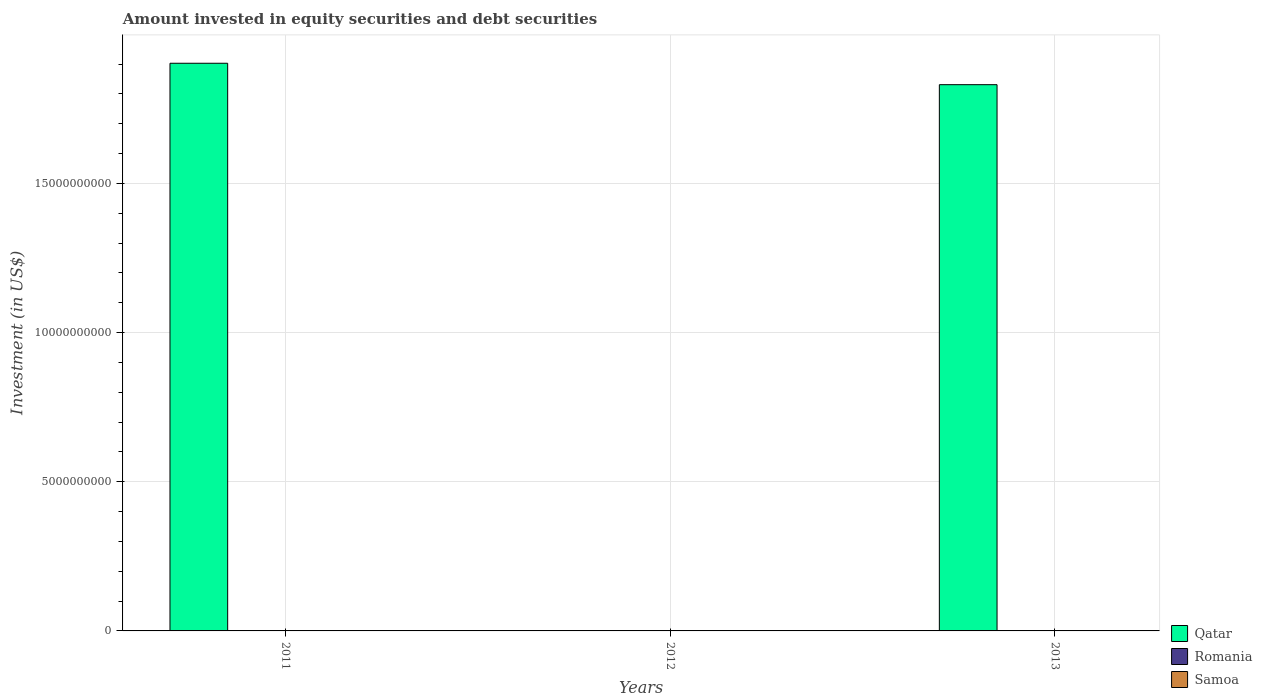Are the number of bars on each tick of the X-axis equal?
Provide a short and direct response. No. What is the label of the 3rd group of bars from the left?
Keep it short and to the point. 2013. What is the amount invested in equity securities and debt securities in Qatar in 2011?
Provide a succinct answer. 1.90e+1. Across all years, what is the maximum amount invested in equity securities and debt securities in Qatar?
Offer a terse response. 1.90e+1. In which year was the amount invested in equity securities and debt securities in Samoa maximum?
Your answer should be very brief. 2012. What is the total amount invested in equity securities and debt securities in Samoa in the graph?
Make the answer very short. 1.20e+07. What is the difference between the amount invested in equity securities and debt securities in Qatar in 2011 and that in 2013?
Offer a very short reply. 7.18e+08. What is the difference between the amount invested in equity securities and debt securities in Samoa in 2011 and the amount invested in equity securities and debt securities in Romania in 2012?
Provide a short and direct response. 3.80e+05. In the year 2011, what is the difference between the amount invested in equity securities and debt securities in Samoa and amount invested in equity securities and debt securities in Qatar?
Your answer should be very brief. -1.90e+1. In how many years, is the amount invested in equity securities and debt securities in Samoa greater than 4000000000 US$?
Your answer should be compact. 0. What is the ratio of the amount invested in equity securities and debt securities in Qatar in 2011 to that in 2013?
Your response must be concise. 1.04. Is the difference between the amount invested in equity securities and debt securities in Samoa in 2011 and 2013 greater than the difference between the amount invested in equity securities and debt securities in Qatar in 2011 and 2013?
Provide a short and direct response. No. What is the difference between the highest and the second highest amount invested in equity securities and debt securities in Samoa?
Your response must be concise. 8.18e+06. What is the difference between the highest and the lowest amount invested in equity securities and debt securities in Samoa?
Your response must be concise. 9.52e+06. Is the sum of the amount invested in equity securities and debt securities in Samoa in 2012 and 2013 greater than the maximum amount invested in equity securities and debt securities in Romania across all years?
Provide a short and direct response. Yes. Is it the case that in every year, the sum of the amount invested in equity securities and debt securities in Samoa and amount invested in equity securities and debt securities in Romania is greater than the amount invested in equity securities and debt securities in Qatar?
Provide a short and direct response. No. How many bars are there?
Give a very brief answer. 5. How many years are there in the graph?
Make the answer very short. 3. Are the values on the major ticks of Y-axis written in scientific E-notation?
Your answer should be compact. No. Does the graph contain any zero values?
Give a very brief answer. Yes. Does the graph contain grids?
Ensure brevity in your answer.  Yes. Where does the legend appear in the graph?
Keep it short and to the point. Bottom right. How many legend labels are there?
Your answer should be compact. 3. What is the title of the graph?
Ensure brevity in your answer.  Amount invested in equity securities and debt securities. What is the label or title of the Y-axis?
Keep it short and to the point. Investment (in US$). What is the Investment (in US$) of Qatar in 2011?
Make the answer very short. 1.90e+1. What is the Investment (in US$) in Romania in 2011?
Offer a very short reply. 0. What is the Investment (in US$) of Samoa in 2011?
Your answer should be compact. 3.80e+05. What is the Investment (in US$) in Romania in 2012?
Provide a succinct answer. 0. What is the Investment (in US$) in Samoa in 2012?
Offer a terse response. 9.90e+06. What is the Investment (in US$) in Qatar in 2013?
Your response must be concise. 1.83e+1. What is the Investment (in US$) in Romania in 2013?
Keep it short and to the point. 0. What is the Investment (in US$) of Samoa in 2013?
Offer a terse response. 1.72e+06. Across all years, what is the maximum Investment (in US$) in Qatar?
Offer a terse response. 1.90e+1. Across all years, what is the maximum Investment (in US$) of Samoa?
Give a very brief answer. 9.90e+06. Across all years, what is the minimum Investment (in US$) of Samoa?
Keep it short and to the point. 3.80e+05. What is the total Investment (in US$) of Qatar in the graph?
Your response must be concise. 3.73e+1. What is the total Investment (in US$) in Samoa in the graph?
Give a very brief answer. 1.20e+07. What is the difference between the Investment (in US$) in Samoa in 2011 and that in 2012?
Your answer should be very brief. -9.52e+06. What is the difference between the Investment (in US$) in Qatar in 2011 and that in 2013?
Keep it short and to the point. 7.18e+08. What is the difference between the Investment (in US$) in Samoa in 2011 and that in 2013?
Keep it short and to the point. -1.34e+06. What is the difference between the Investment (in US$) of Samoa in 2012 and that in 2013?
Give a very brief answer. 8.18e+06. What is the difference between the Investment (in US$) of Qatar in 2011 and the Investment (in US$) of Samoa in 2012?
Provide a succinct answer. 1.90e+1. What is the difference between the Investment (in US$) in Qatar in 2011 and the Investment (in US$) in Samoa in 2013?
Offer a very short reply. 1.90e+1. What is the average Investment (in US$) in Qatar per year?
Offer a terse response. 1.24e+1. What is the average Investment (in US$) of Samoa per year?
Offer a terse response. 4.00e+06. In the year 2011, what is the difference between the Investment (in US$) in Qatar and Investment (in US$) in Samoa?
Make the answer very short. 1.90e+1. In the year 2013, what is the difference between the Investment (in US$) in Qatar and Investment (in US$) in Samoa?
Keep it short and to the point. 1.83e+1. What is the ratio of the Investment (in US$) of Samoa in 2011 to that in 2012?
Your answer should be very brief. 0.04. What is the ratio of the Investment (in US$) in Qatar in 2011 to that in 2013?
Your response must be concise. 1.04. What is the ratio of the Investment (in US$) in Samoa in 2011 to that in 2013?
Make the answer very short. 0.22. What is the ratio of the Investment (in US$) of Samoa in 2012 to that in 2013?
Offer a very short reply. 5.75. What is the difference between the highest and the second highest Investment (in US$) in Samoa?
Keep it short and to the point. 8.18e+06. What is the difference between the highest and the lowest Investment (in US$) in Qatar?
Your answer should be very brief. 1.90e+1. What is the difference between the highest and the lowest Investment (in US$) of Samoa?
Make the answer very short. 9.52e+06. 